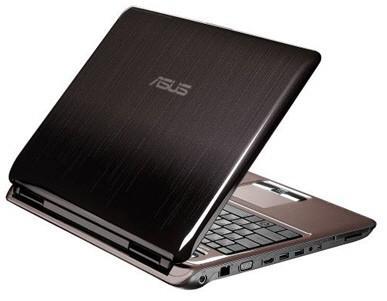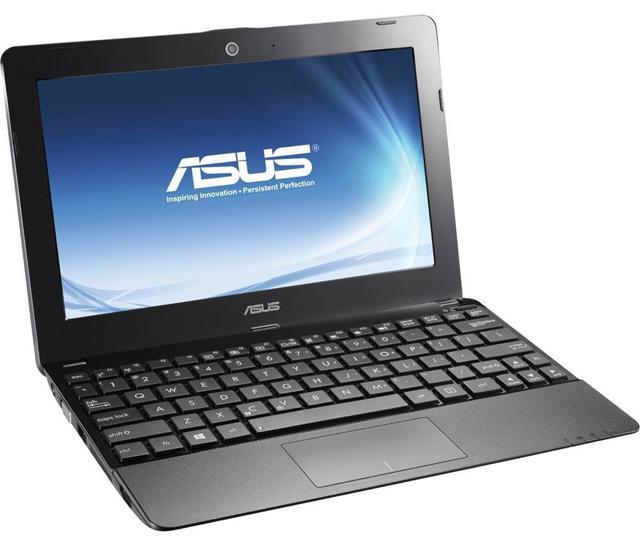The first image is the image on the left, the second image is the image on the right. For the images shown, is this caption "Each image shows a single open laptop, and each laptop is open to an angle of at least 90 degrees." true? Answer yes or no. No. The first image is the image on the left, the second image is the image on the right. Examine the images to the left and right. Is the description "some keyboards have white/gray keys." accurate? Answer yes or no. No. 